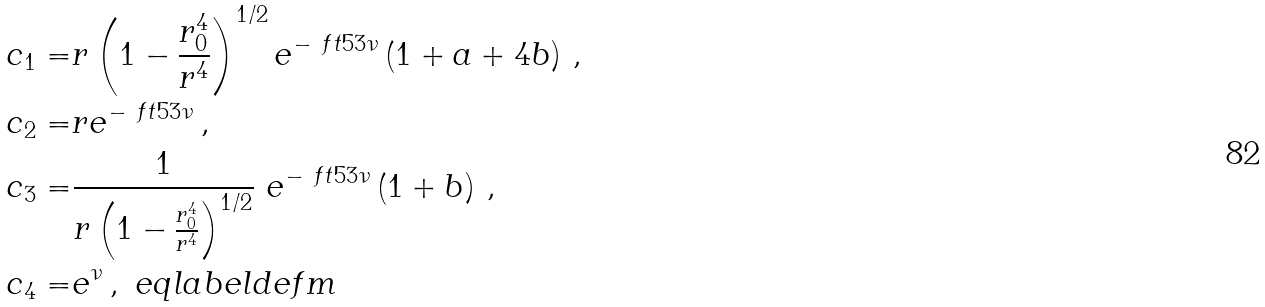<formula> <loc_0><loc_0><loc_500><loc_500>c _ { 1 } = & r \left ( 1 - \frac { r _ { 0 } ^ { 4 } } { r ^ { 4 } } \right ) ^ { 1 / 2 } e ^ { - \ f t 5 3 \nu } \left ( 1 + a + 4 b \right ) \, , \\ c _ { 2 } = & r e ^ { - \ f t 5 3 \nu } \, , \\ c _ { 3 } = & \frac { 1 } { r \left ( 1 - \frac { r _ { 0 } ^ { 4 } } { r ^ { 4 } } \right ) ^ { 1 / 2 } } \ e ^ { - \ f t 5 3 \nu } \left ( 1 + b \right ) \, , \\ c _ { 4 } = & e ^ { \nu } \, , \ e q l a b e l { d e f m }</formula> 